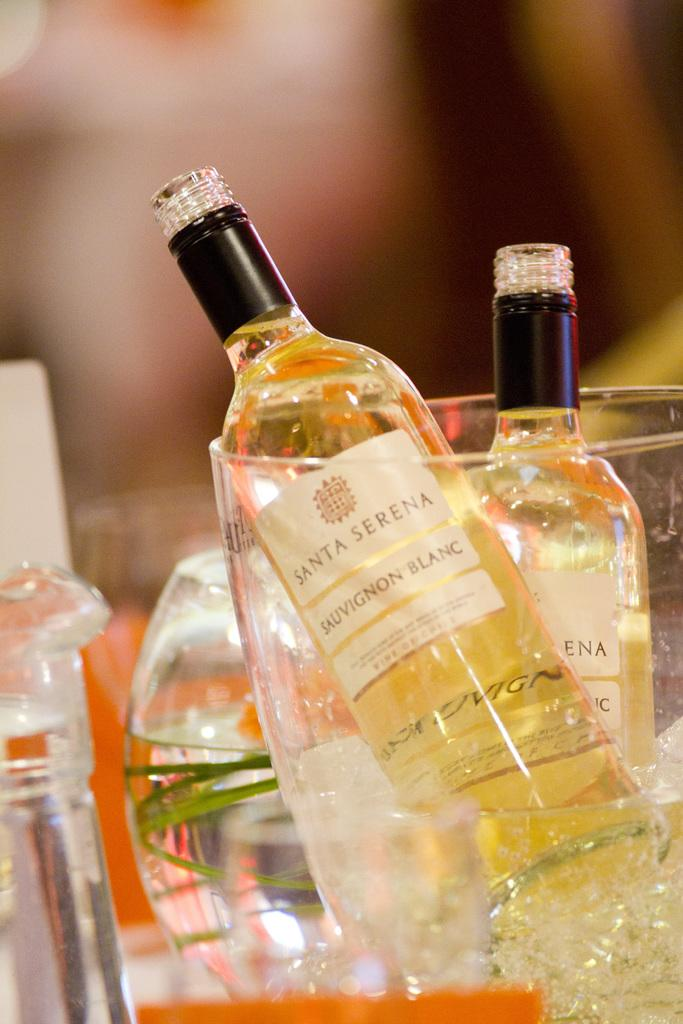<image>
Share a concise interpretation of the image provided. Two tiny bottles of Santa Serena Sauvignon Blanc wine laying in glass. 